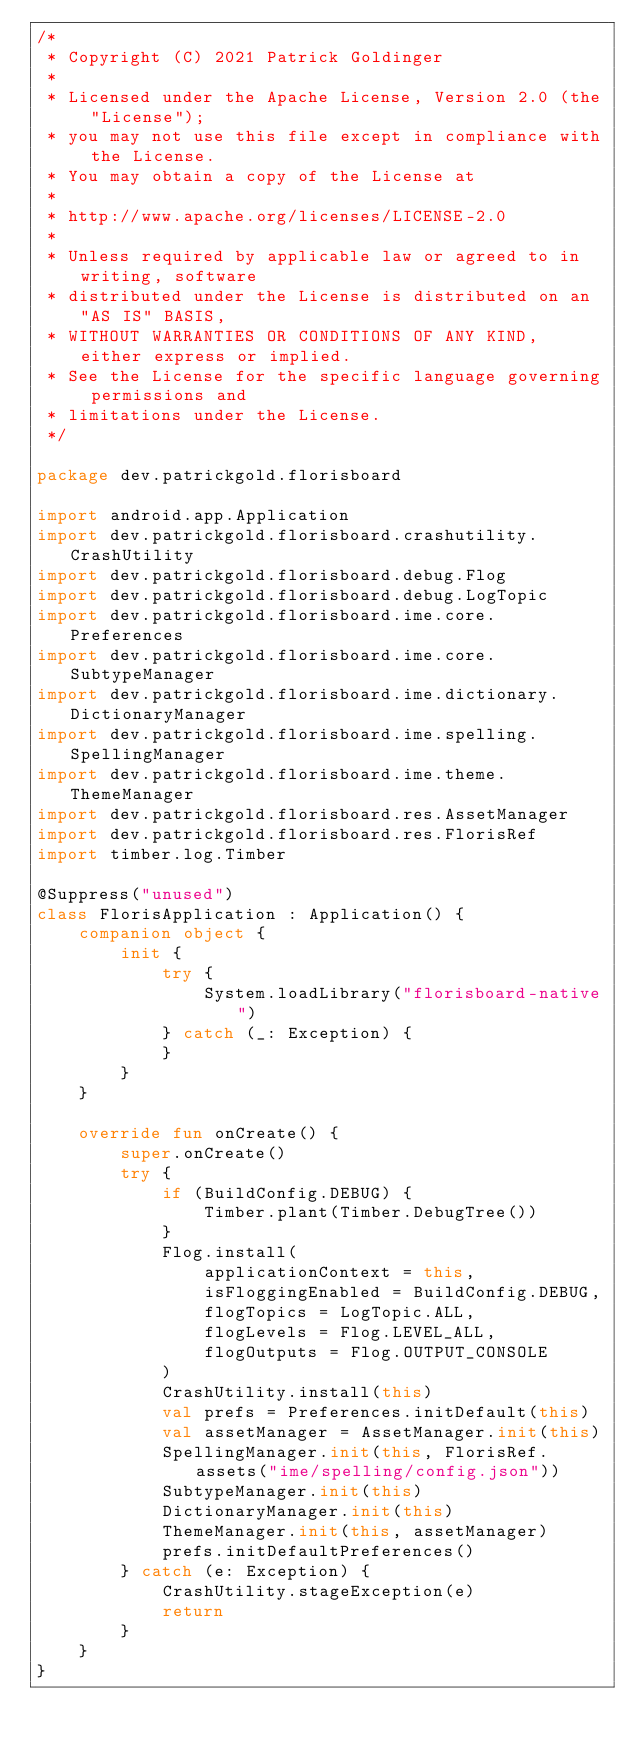Convert code to text. <code><loc_0><loc_0><loc_500><loc_500><_Kotlin_>/*
 * Copyright (C) 2021 Patrick Goldinger
 *
 * Licensed under the Apache License, Version 2.0 (the "License");
 * you may not use this file except in compliance with the License.
 * You may obtain a copy of the License at
 *
 * http://www.apache.org/licenses/LICENSE-2.0
 *
 * Unless required by applicable law or agreed to in writing, software
 * distributed under the License is distributed on an "AS IS" BASIS,
 * WITHOUT WARRANTIES OR CONDITIONS OF ANY KIND, either express or implied.
 * See the License for the specific language governing permissions and
 * limitations under the License.
 */

package dev.patrickgold.florisboard

import android.app.Application
import dev.patrickgold.florisboard.crashutility.CrashUtility
import dev.patrickgold.florisboard.debug.Flog
import dev.patrickgold.florisboard.debug.LogTopic
import dev.patrickgold.florisboard.ime.core.Preferences
import dev.patrickgold.florisboard.ime.core.SubtypeManager
import dev.patrickgold.florisboard.ime.dictionary.DictionaryManager
import dev.patrickgold.florisboard.ime.spelling.SpellingManager
import dev.patrickgold.florisboard.ime.theme.ThemeManager
import dev.patrickgold.florisboard.res.AssetManager
import dev.patrickgold.florisboard.res.FlorisRef
import timber.log.Timber

@Suppress("unused")
class FlorisApplication : Application() {
    companion object {
        init {
            try {
                System.loadLibrary("florisboard-native")
            } catch (_: Exception) {
            }
        }
    }

    override fun onCreate() {
        super.onCreate()
        try {
            if (BuildConfig.DEBUG) {
                Timber.plant(Timber.DebugTree())
            }
            Flog.install(
                applicationContext = this,
                isFloggingEnabled = BuildConfig.DEBUG,
                flogTopics = LogTopic.ALL,
                flogLevels = Flog.LEVEL_ALL,
                flogOutputs = Flog.OUTPUT_CONSOLE
            )
            CrashUtility.install(this)
            val prefs = Preferences.initDefault(this)
            val assetManager = AssetManager.init(this)
            SpellingManager.init(this, FlorisRef.assets("ime/spelling/config.json"))
            SubtypeManager.init(this)
            DictionaryManager.init(this)
            ThemeManager.init(this, assetManager)
            prefs.initDefaultPreferences()
        } catch (e: Exception) {
            CrashUtility.stageException(e)
            return
        }
    }
}
</code> 